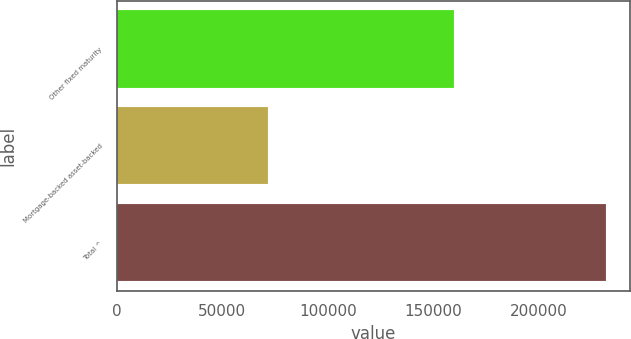Convert chart to OTSL. <chart><loc_0><loc_0><loc_500><loc_500><bar_chart><fcel>Other fixed maturity<fcel>Mortgage-backed asset-backed<fcel>Total ^<nl><fcel>159825<fcel>71817<fcel>231642<nl></chart> 